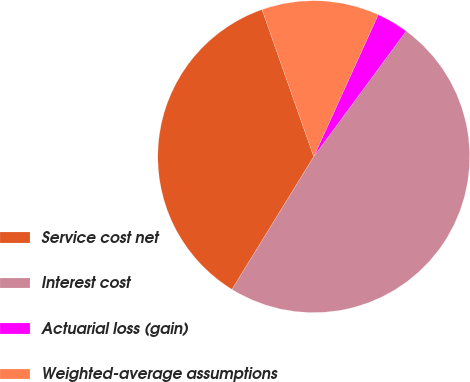Convert chart. <chart><loc_0><loc_0><loc_500><loc_500><pie_chart><fcel>Service cost net<fcel>Interest cost<fcel>Actuarial loss (gain)<fcel>Weighted-average assumptions<nl><fcel>35.83%<fcel>48.69%<fcel>3.31%<fcel>12.17%<nl></chart> 